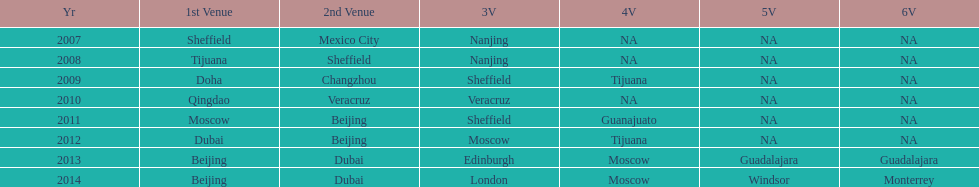What years had the most venues? 2013, 2014. 